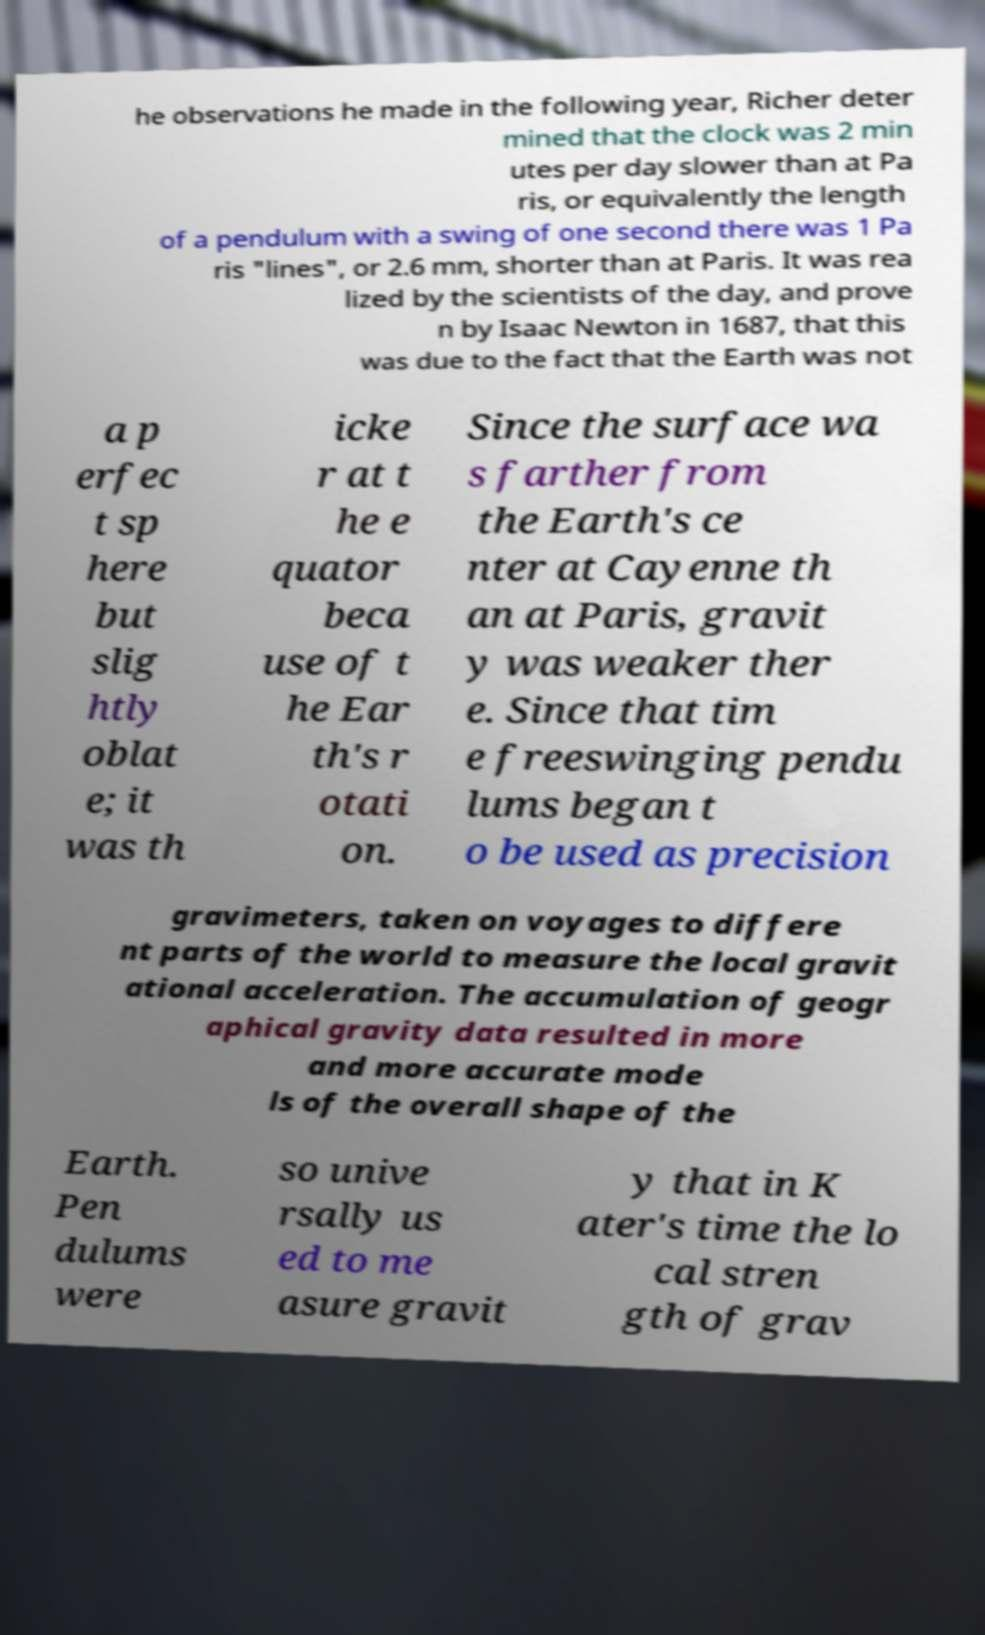Can you accurately transcribe the text from the provided image for me? he observations he made in the following year, Richer deter mined that the clock was 2 min utes per day slower than at Pa ris, or equivalently the length of a pendulum with a swing of one second there was 1 Pa ris "lines", or 2.6 mm, shorter than at Paris. It was rea lized by the scientists of the day, and prove n by Isaac Newton in 1687, that this was due to the fact that the Earth was not a p erfec t sp here but slig htly oblat e; it was th icke r at t he e quator beca use of t he Ear th's r otati on. Since the surface wa s farther from the Earth's ce nter at Cayenne th an at Paris, gravit y was weaker ther e. Since that tim e freeswinging pendu lums began t o be used as precision gravimeters, taken on voyages to differe nt parts of the world to measure the local gravit ational acceleration. The accumulation of geogr aphical gravity data resulted in more and more accurate mode ls of the overall shape of the Earth. Pen dulums were so unive rsally us ed to me asure gravit y that in K ater's time the lo cal stren gth of grav 